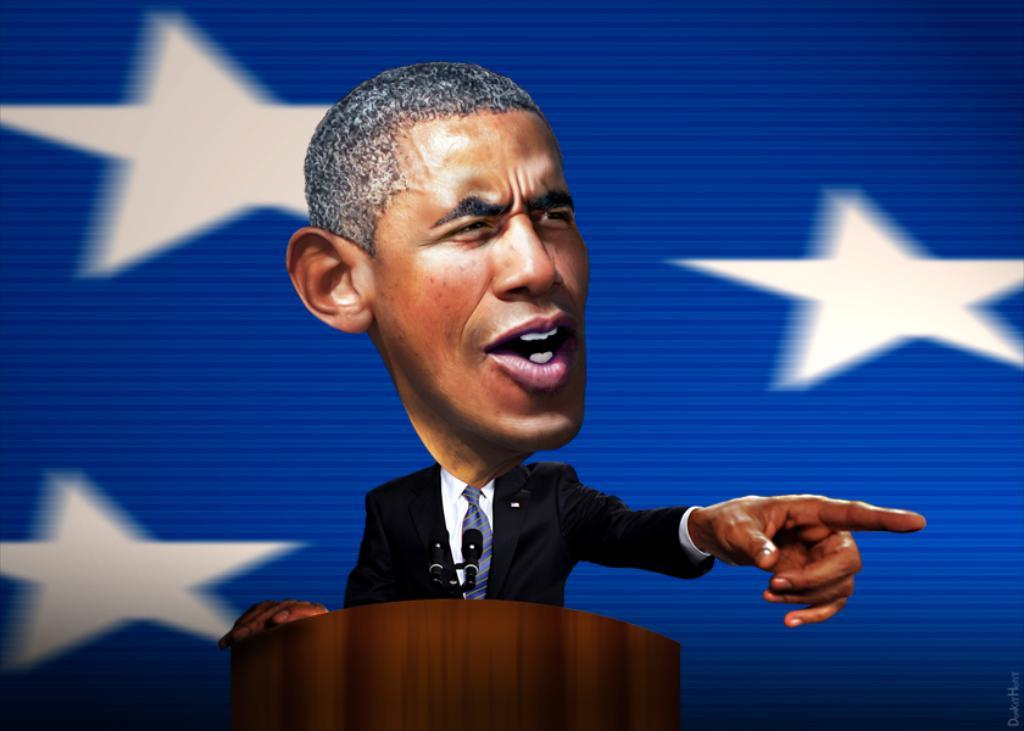What is the person in the image doing? There is a person standing in front of the podium in the image. What can be seen on the podium? There are two microphones on the podium. What can be seen in the sky in the image? A few stars are visible in the image. What is the color of the background in the image? The background color is blue. What songs is the person singing in the image? There is no indication in the image that the person is singing, and no songs can be heard or seen. 